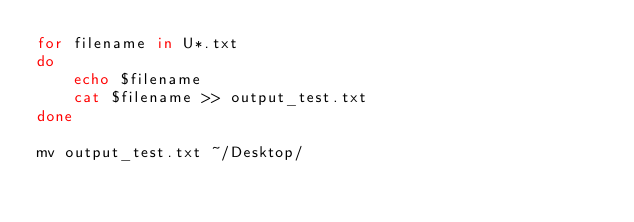Convert code to text. <code><loc_0><loc_0><loc_500><loc_500><_Bash_>for filename in U*.txt
do
    echo $filename
    cat $filename >> output_test.txt
done

mv output_test.txt ~/Desktop/
</code> 